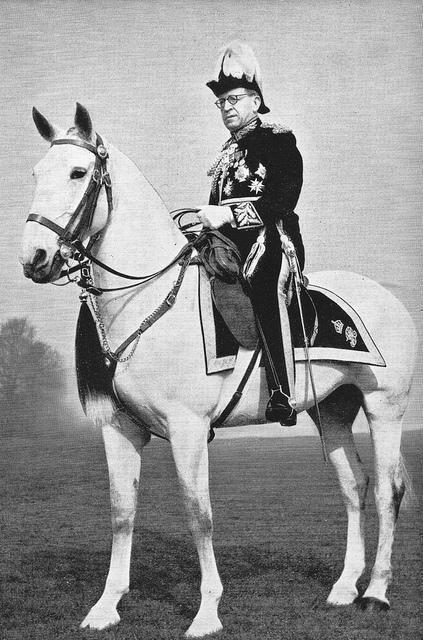What did this man serve in?
From the following set of four choices, select the accurate answer to respond to the question.
Options: Tennis, military, dog grooming, horse show. Military. 